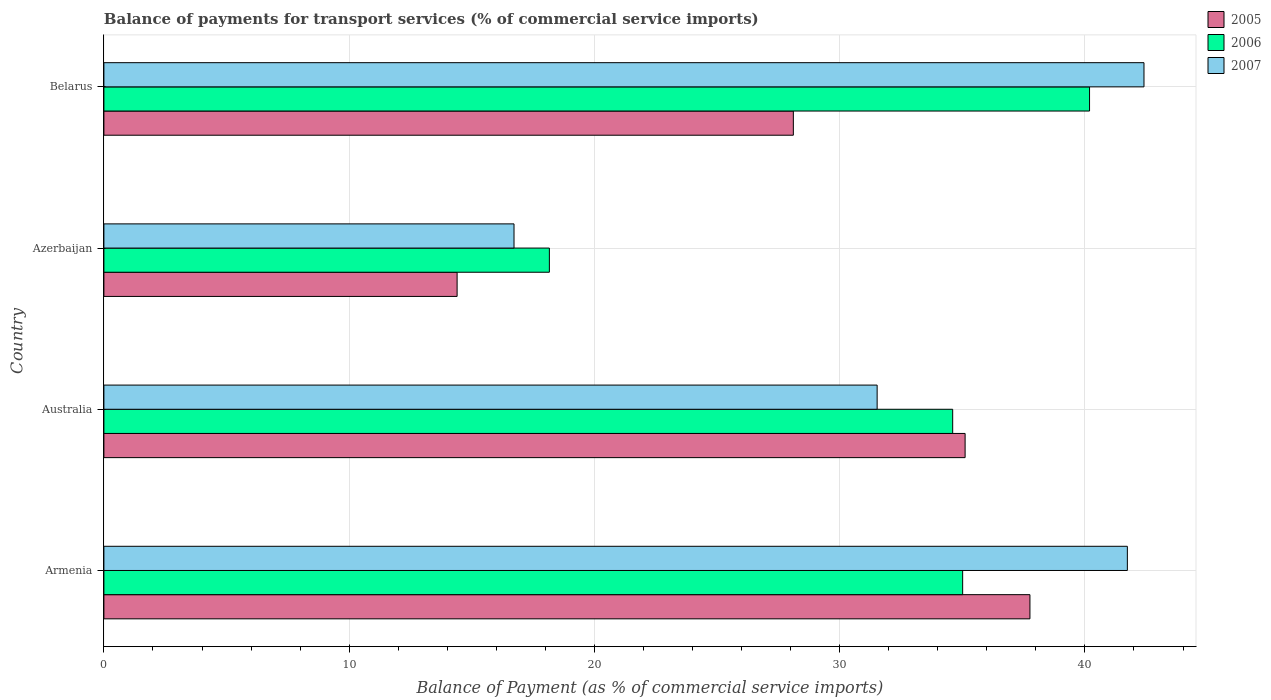Are the number of bars per tick equal to the number of legend labels?
Offer a very short reply. Yes. What is the label of the 1st group of bars from the top?
Offer a very short reply. Belarus. In how many cases, is the number of bars for a given country not equal to the number of legend labels?
Provide a short and direct response. 0. What is the balance of payments for transport services in 2005 in Armenia?
Keep it short and to the point. 37.76. Across all countries, what is the maximum balance of payments for transport services in 2006?
Offer a terse response. 40.19. Across all countries, what is the minimum balance of payments for transport services in 2005?
Your answer should be compact. 14.4. In which country was the balance of payments for transport services in 2007 maximum?
Offer a very short reply. Belarus. In which country was the balance of payments for transport services in 2005 minimum?
Give a very brief answer. Azerbaijan. What is the total balance of payments for transport services in 2005 in the graph?
Give a very brief answer. 115.38. What is the difference between the balance of payments for transport services in 2006 in Australia and that in Belarus?
Your response must be concise. -5.58. What is the difference between the balance of payments for transport services in 2007 in Azerbaijan and the balance of payments for transport services in 2006 in Armenia?
Keep it short and to the point. -18.29. What is the average balance of payments for transport services in 2007 per country?
Ensure brevity in your answer.  33.1. What is the difference between the balance of payments for transport services in 2006 and balance of payments for transport services in 2007 in Australia?
Keep it short and to the point. 3.08. What is the ratio of the balance of payments for transport services in 2007 in Azerbaijan to that in Belarus?
Your answer should be compact. 0.39. Is the balance of payments for transport services in 2005 in Armenia less than that in Azerbaijan?
Offer a very short reply. No. What is the difference between the highest and the second highest balance of payments for transport services in 2005?
Offer a very short reply. 2.64. What is the difference between the highest and the lowest balance of payments for transport services in 2007?
Keep it short and to the point. 25.69. In how many countries, is the balance of payments for transport services in 2005 greater than the average balance of payments for transport services in 2005 taken over all countries?
Keep it short and to the point. 2. Is the sum of the balance of payments for transport services in 2007 in Australia and Belarus greater than the maximum balance of payments for transport services in 2006 across all countries?
Offer a very short reply. Yes. What does the 3rd bar from the bottom in Azerbaijan represents?
Your response must be concise. 2007. How many countries are there in the graph?
Give a very brief answer. 4. Where does the legend appear in the graph?
Make the answer very short. Top right. How are the legend labels stacked?
Your answer should be compact. Vertical. What is the title of the graph?
Provide a succinct answer. Balance of payments for transport services (% of commercial service imports). Does "2015" appear as one of the legend labels in the graph?
Keep it short and to the point. No. What is the label or title of the X-axis?
Your answer should be compact. Balance of Payment (as % of commercial service imports). What is the Balance of Payment (as % of commercial service imports) of 2005 in Armenia?
Your answer should be very brief. 37.76. What is the Balance of Payment (as % of commercial service imports) in 2006 in Armenia?
Offer a very short reply. 35.01. What is the Balance of Payment (as % of commercial service imports) in 2007 in Armenia?
Offer a very short reply. 41.73. What is the Balance of Payment (as % of commercial service imports) of 2005 in Australia?
Provide a short and direct response. 35.11. What is the Balance of Payment (as % of commercial service imports) of 2006 in Australia?
Make the answer very short. 34.61. What is the Balance of Payment (as % of commercial service imports) of 2007 in Australia?
Ensure brevity in your answer.  31.53. What is the Balance of Payment (as % of commercial service imports) in 2005 in Azerbaijan?
Give a very brief answer. 14.4. What is the Balance of Payment (as % of commercial service imports) in 2006 in Azerbaijan?
Your response must be concise. 18.16. What is the Balance of Payment (as % of commercial service imports) of 2007 in Azerbaijan?
Offer a terse response. 16.72. What is the Balance of Payment (as % of commercial service imports) of 2005 in Belarus?
Your answer should be very brief. 28.11. What is the Balance of Payment (as % of commercial service imports) of 2006 in Belarus?
Give a very brief answer. 40.19. What is the Balance of Payment (as % of commercial service imports) in 2007 in Belarus?
Keep it short and to the point. 42.41. Across all countries, what is the maximum Balance of Payment (as % of commercial service imports) of 2005?
Keep it short and to the point. 37.76. Across all countries, what is the maximum Balance of Payment (as % of commercial service imports) in 2006?
Keep it short and to the point. 40.19. Across all countries, what is the maximum Balance of Payment (as % of commercial service imports) in 2007?
Make the answer very short. 42.41. Across all countries, what is the minimum Balance of Payment (as % of commercial service imports) of 2005?
Keep it short and to the point. 14.4. Across all countries, what is the minimum Balance of Payment (as % of commercial service imports) of 2006?
Provide a succinct answer. 18.16. Across all countries, what is the minimum Balance of Payment (as % of commercial service imports) in 2007?
Your response must be concise. 16.72. What is the total Balance of Payment (as % of commercial service imports) of 2005 in the graph?
Offer a very short reply. 115.38. What is the total Balance of Payment (as % of commercial service imports) in 2006 in the graph?
Your answer should be very brief. 127.97. What is the total Balance of Payment (as % of commercial service imports) of 2007 in the graph?
Your answer should be compact. 132.39. What is the difference between the Balance of Payment (as % of commercial service imports) of 2005 in Armenia and that in Australia?
Your answer should be very brief. 2.64. What is the difference between the Balance of Payment (as % of commercial service imports) of 2006 in Armenia and that in Australia?
Your response must be concise. 0.41. What is the difference between the Balance of Payment (as % of commercial service imports) of 2007 in Armenia and that in Australia?
Provide a short and direct response. 10.2. What is the difference between the Balance of Payment (as % of commercial service imports) of 2005 in Armenia and that in Azerbaijan?
Make the answer very short. 23.36. What is the difference between the Balance of Payment (as % of commercial service imports) of 2006 in Armenia and that in Azerbaijan?
Provide a short and direct response. 16.85. What is the difference between the Balance of Payment (as % of commercial service imports) in 2007 in Armenia and that in Azerbaijan?
Ensure brevity in your answer.  25.01. What is the difference between the Balance of Payment (as % of commercial service imports) of 2005 in Armenia and that in Belarus?
Ensure brevity in your answer.  9.65. What is the difference between the Balance of Payment (as % of commercial service imports) of 2006 in Armenia and that in Belarus?
Your answer should be very brief. -5.17. What is the difference between the Balance of Payment (as % of commercial service imports) in 2007 in Armenia and that in Belarus?
Give a very brief answer. -0.68. What is the difference between the Balance of Payment (as % of commercial service imports) of 2005 in Australia and that in Azerbaijan?
Your answer should be compact. 20.71. What is the difference between the Balance of Payment (as % of commercial service imports) of 2006 in Australia and that in Azerbaijan?
Your answer should be compact. 16.44. What is the difference between the Balance of Payment (as % of commercial service imports) of 2007 in Australia and that in Azerbaijan?
Offer a terse response. 14.81. What is the difference between the Balance of Payment (as % of commercial service imports) in 2005 in Australia and that in Belarus?
Your answer should be very brief. 7. What is the difference between the Balance of Payment (as % of commercial service imports) of 2006 in Australia and that in Belarus?
Your answer should be compact. -5.58. What is the difference between the Balance of Payment (as % of commercial service imports) in 2007 in Australia and that in Belarus?
Provide a succinct answer. -10.88. What is the difference between the Balance of Payment (as % of commercial service imports) in 2005 in Azerbaijan and that in Belarus?
Your answer should be very brief. -13.71. What is the difference between the Balance of Payment (as % of commercial service imports) of 2006 in Azerbaijan and that in Belarus?
Your response must be concise. -22.02. What is the difference between the Balance of Payment (as % of commercial service imports) of 2007 in Azerbaijan and that in Belarus?
Your answer should be very brief. -25.69. What is the difference between the Balance of Payment (as % of commercial service imports) in 2005 in Armenia and the Balance of Payment (as % of commercial service imports) in 2006 in Australia?
Keep it short and to the point. 3.15. What is the difference between the Balance of Payment (as % of commercial service imports) of 2005 in Armenia and the Balance of Payment (as % of commercial service imports) of 2007 in Australia?
Keep it short and to the point. 6.23. What is the difference between the Balance of Payment (as % of commercial service imports) in 2006 in Armenia and the Balance of Payment (as % of commercial service imports) in 2007 in Australia?
Make the answer very short. 3.49. What is the difference between the Balance of Payment (as % of commercial service imports) of 2005 in Armenia and the Balance of Payment (as % of commercial service imports) of 2006 in Azerbaijan?
Provide a short and direct response. 19.59. What is the difference between the Balance of Payment (as % of commercial service imports) of 2005 in Armenia and the Balance of Payment (as % of commercial service imports) of 2007 in Azerbaijan?
Provide a succinct answer. 21.04. What is the difference between the Balance of Payment (as % of commercial service imports) of 2006 in Armenia and the Balance of Payment (as % of commercial service imports) of 2007 in Azerbaijan?
Offer a very short reply. 18.29. What is the difference between the Balance of Payment (as % of commercial service imports) of 2005 in Armenia and the Balance of Payment (as % of commercial service imports) of 2006 in Belarus?
Your answer should be very brief. -2.43. What is the difference between the Balance of Payment (as % of commercial service imports) of 2005 in Armenia and the Balance of Payment (as % of commercial service imports) of 2007 in Belarus?
Give a very brief answer. -4.65. What is the difference between the Balance of Payment (as % of commercial service imports) of 2006 in Armenia and the Balance of Payment (as % of commercial service imports) of 2007 in Belarus?
Provide a succinct answer. -7.39. What is the difference between the Balance of Payment (as % of commercial service imports) of 2005 in Australia and the Balance of Payment (as % of commercial service imports) of 2006 in Azerbaijan?
Provide a short and direct response. 16.95. What is the difference between the Balance of Payment (as % of commercial service imports) of 2005 in Australia and the Balance of Payment (as % of commercial service imports) of 2007 in Azerbaijan?
Make the answer very short. 18.39. What is the difference between the Balance of Payment (as % of commercial service imports) of 2006 in Australia and the Balance of Payment (as % of commercial service imports) of 2007 in Azerbaijan?
Keep it short and to the point. 17.89. What is the difference between the Balance of Payment (as % of commercial service imports) of 2005 in Australia and the Balance of Payment (as % of commercial service imports) of 2006 in Belarus?
Provide a succinct answer. -5.07. What is the difference between the Balance of Payment (as % of commercial service imports) of 2005 in Australia and the Balance of Payment (as % of commercial service imports) of 2007 in Belarus?
Your answer should be very brief. -7.29. What is the difference between the Balance of Payment (as % of commercial service imports) of 2006 in Australia and the Balance of Payment (as % of commercial service imports) of 2007 in Belarus?
Provide a short and direct response. -7.8. What is the difference between the Balance of Payment (as % of commercial service imports) of 2005 in Azerbaijan and the Balance of Payment (as % of commercial service imports) of 2006 in Belarus?
Offer a very short reply. -25.79. What is the difference between the Balance of Payment (as % of commercial service imports) of 2005 in Azerbaijan and the Balance of Payment (as % of commercial service imports) of 2007 in Belarus?
Your answer should be very brief. -28.01. What is the difference between the Balance of Payment (as % of commercial service imports) of 2006 in Azerbaijan and the Balance of Payment (as % of commercial service imports) of 2007 in Belarus?
Ensure brevity in your answer.  -24.24. What is the average Balance of Payment (as % of commercial service imports) in 2005 per country?
Ensure brevity in your answer.  28.85. What is the average Balance of Payment (as % of commercial service imports) of 2006 per country?
Your response must be concise. 31.99. What is the average Balance of Payment (as % of commercial service imports) in 2007 per country?
Your response must be concise. 33.1. What is the difference between the Balance of Payment (as % of commercial service imports) in 2005 and Balance of Payment (as % of commercial service imports) in 2006 in Armenia?
Offer a very short reply. 2.74. What is the difference between the Balance of Payment (as % of commercial service imports) in 2005 and Balance of Payment (as % of commercial service imports) in 2007 in Armenia?
Offer a very short reply. -3.97. What is the difference between the Balance of Payment (as % of commercial service imports) in 2006 and Balance of Payment (as % of commercial service imports) in 2007 in Armenia?
Offer a very short reply. -6.72. What is the difference between the Balance of Payment (as % of commercial service imports) in 2005 and Balance of Payment (as % of commercial service imports) in 2006 in Australia?
Keep it short and to the point. 0.51. What is the difference between the Balance of Payment (as % of commercial service imports) in 2005 and Balance of Payment (as % of commercial service imports) in 2007 in Australia?
Offer a very short reply. 3.59. What is the difference between the Balance of Payment (as % of commercial service imports) in 2006 and Balance of Payment (as % of commercial service imports) in 2007 in Australia?
Your response must be concise. 3.08. What is the difference between the Balance of Payment (as % of commercial service imports) in 2005 and Balance of Payment (as % of commercial service imports) in 2006 in Azerbaijan?
Offer a very short reply. -3.76. What is the difference between the Balance of Payment (as % of commercial service imports) of 2005 and Balance of Payment (as % of commercial service imports) of 2007 in Azerbaijan?
Your response must be concise. -2.32. What is the difference between the Balance of Payment (as % of commercial service imports) in 2006 and Balance of Payment (as % of commercial service imports) in 2007 in Azerbaijan?
Offer a terse response. 1.44. What is the difference between the Balance of Payment (as % of commercial service imports) of 2005 and Balance of Payment (as % of commercial service imports) of 2006 in Belarus?
Give a very brief answer. -12.08. What is the difference between the Balance of Payment (as % of commercial service imports) of 2005 and Balance of Payment (as % of commercial service imports) of 2007 in Belarus?
Your answer should be very brief. -14.3. What is the difference between the Balance of Payment (as % of commercial service imports) of 2006 and Balance of Payment (as % of commercial service imports) of 2007 in Belarus?
Your answer should be compact. -2.22. What is the ratio of the Balance of Payment (as % of commercial service imports) of 2005 in Armenia to that in Australia?
Your answer should be very brief. 1.08. What is the ratio of the Balance of Payment (as % of commercial service imports) in 2006 in Armenia to that in Australia?
Provide a succinct answer. 1.01. What is the ratio of the Balance of Payment (as % of commercial service imports) of 2007 in Armenia to that in Australia?
Your answer should be very brief. 1.32. What is the ratio of the Balance of Payment (as % of commercial service imports) of 2005 in Armenia to that in Azerbaijan?
Your response must be concise. 2.62. What is the ratio of the Balance of Payment (as % of commercial service imports) of 2006 in Armenia to that in Azerbaijan?
Offer a terse response. 1.93. What is the ratio of the Balance of Payment (as % of commercial service imports) in 2007 in Armenia to that in Azerbaijan?
Your answer should be very brief. 2.5. What is the ratio of the Balance of Payment (as % of commercial service imports) of 2005 in Armenia to that in Belarus?
Ensure brevity in your answer.  1.34. What is the ratio of the Balance of Payment (as % of commercial service imports) in 2006 in Armenia to that in Belarus?
Your response must be concise. 0.87. What is the ratio of the Balance of Payment (as % of commercial service imports) in 2005 in Australia to that in Azerbaijan?
Provide a succinct answer. 2.44. What is the ratio of the Balance of Payment (as % of commercial service imports) of 2006 in Australia to that in Azerbaijan?
Offer a very short reply. 1.91. What is the ratio of the Balance of Payment (as % of commercial service imports) in 2007 in Australia to that in Azerbaijan?
Give a very brief answer. 1.89. What is the ratio of the Balance of Payment (as % of commercial service imports) of 2005 in Australia to that in Belarus?
Make the answer very short. 1.25. What is the ratio of the Balance of Payment (as % of commercial service imports) in 2006 in Australia to that in Belarus?
Give a very brief answer. 0.86. What is the ratio of the Balance of Payment (as % of commercial service imports) of 2007 in Australia to that in Belarus?
Offer a very short reply. 0.74. What is the ratio of the Balance of Payment (as % of commercial service imports) of 2005 in Azerbaijan to that in Belarus?
Make the answer very short. 0.51. What is the ratio of the Balance of Payment (as % of commercial service imports) of 2006 in Azerbaijan to that in Belarus?
Provide a succinct answer. 0.45. What is the ratio of the Balance of Payment (as % of commercial service imports) of 2007 in Azerbaijan to that in Belarus?
Your answer should be compact. 0.39. What is the difference between the highest and the second highest Balance of Payment (as % of commercial service imports) in 2005?
Make the answer very short. 2.64. What is the difference between the highest and the second highest Balance of Payment (as % of commercial service imports) of 2006?
Offer a terse response. 5.17. What is the difference between the highest and the second highest Balance of Payment (as % of commercial service imports) in 2007?
Your response must be concise. 0.68. What is the difference between the highest and the lowest Balance of Payment (as % of commercial service imports) of 2005?
Offer a terse response. 23.36. What is the difference between the highest and the lowest Balance of Payment (as % of commercial service imports) in 2006?
Offer a very short reply. 22.02. What is the difference between the highest and the lowest Balance of Payment (as % of commercial service imports) in 2007?
Give a very brief answer. 25.69. 